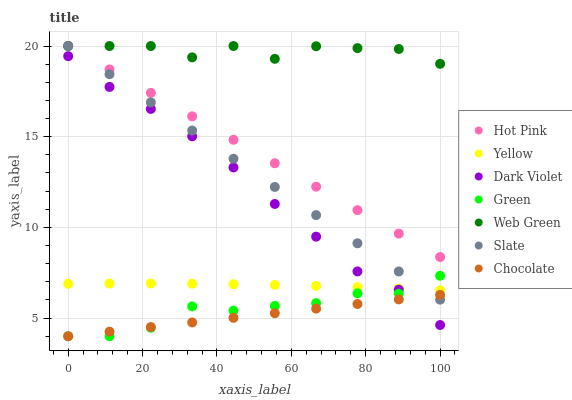Does Chocolate have the minimum area under the curve?
Answer yes or no. Yes. Does Web Green have the maximum area under the curve?
Answer yes or no. Yes. Does Hot Pink have the minimum area under the curve?
Answer yes or no. No. Does Hot Pink have the maximum area under the curve?
Answer yes or no. No. Is Chocolate the smoothest?
Answer yes or no. Yes. Is Web Green the roughest?
Answer yes or no. Yes. Is Hot Pink the smoothest?
Answer yes or no. No. Is Hot Pink the roughest?
Answer yes or no. No. Does Chocolate have the lowest value?
Answer yes or no. Yes. Does Hot Pink have the lowest value?
Answer yes or no. No. Does Web Green have the highest value?
Answer yes or no. Yes. Does Chocolate have the highest value?
Answer yes or no. No. Is Dark Violet less than Slate?
Answer yes or no. Yes. Is Hot Pink greater than Green?
Answer yes or no. Yes. Does Slate intersect Hot Pink?
Answer yes or no. Yes. Is Slate less than Hot Pink?
Answer yes or no. No. Is Slate greater than Hot Pink?
Answer yes or no. No. Does Dark Violet intersect Slate?
Answer yes or no. No. 